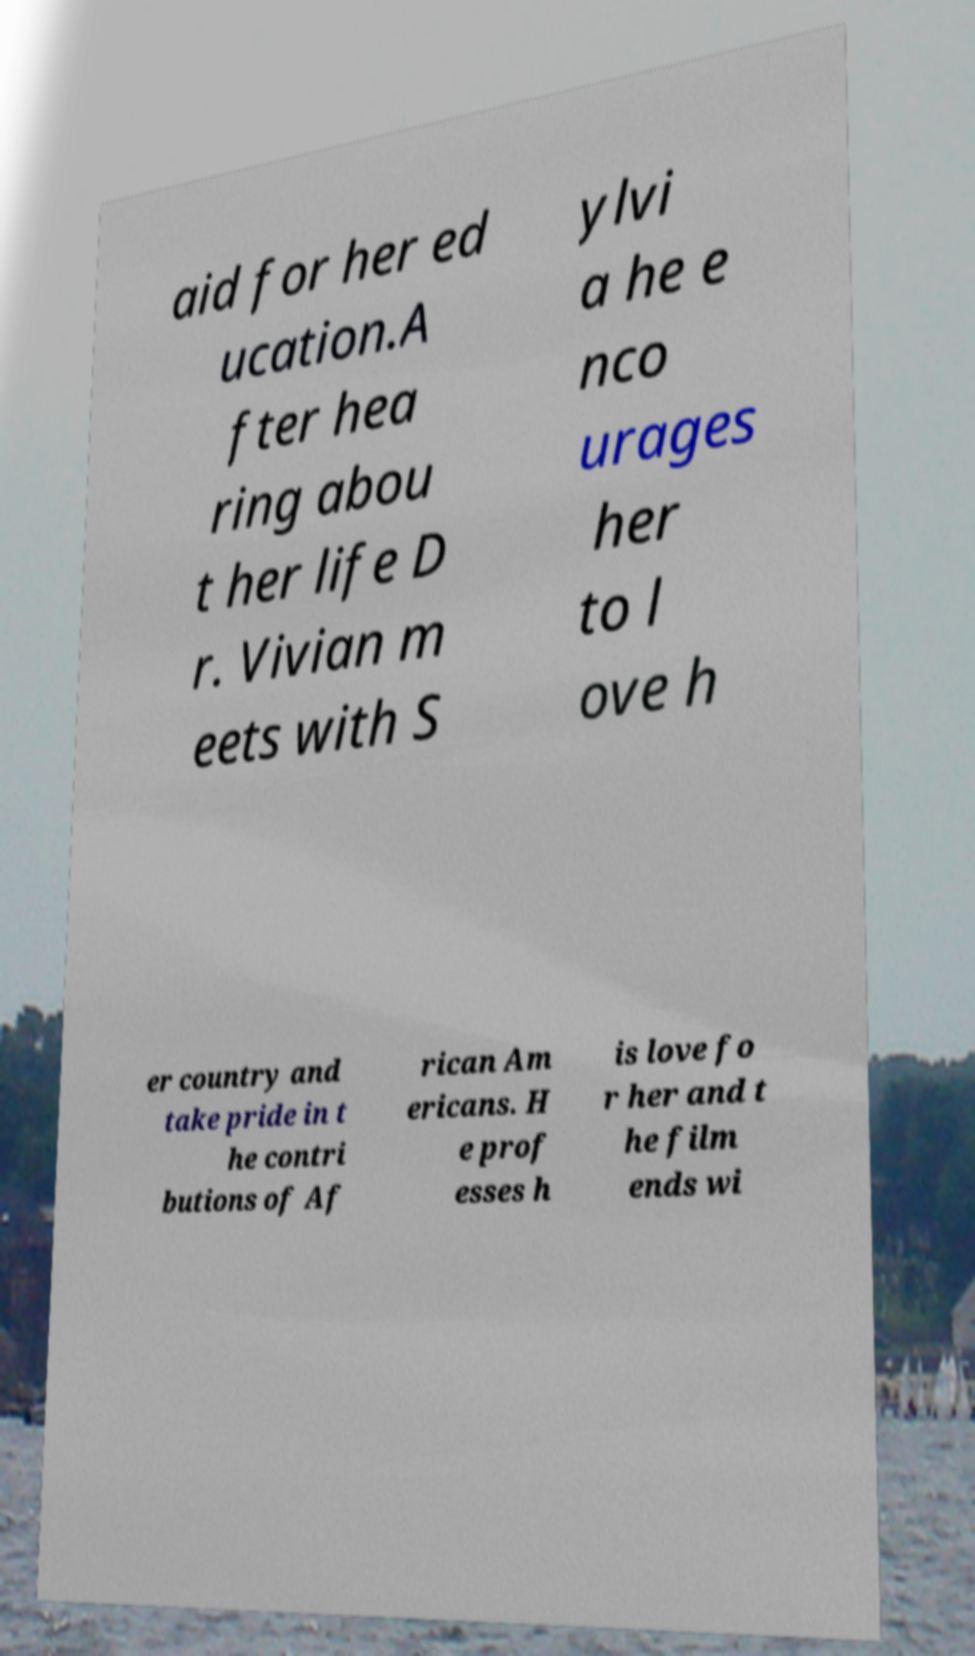There's text embedded in this image that I need extracted. Can you transcribe it verbatim? aid for her ed ucation.A fter hea ring abou t her life D r. Vivian m eets with S ylvi a he e nco urages her to l ove h er country and take pride in t he contri butions of Af rican Am ericans. H e prof esses h is love fo r her and t he film ends wi 